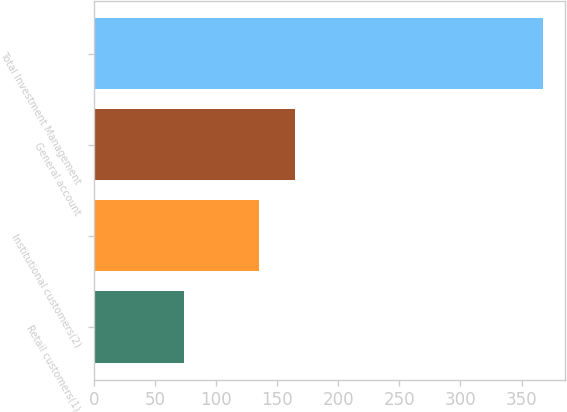Convert chart to OTSL. <chart><loc_0><loc_0><loc_500><loc_500><bar_chart><fcel>Retail customers(1)<fcel>Institutional customers(2)<fcel>General account<fcel>Total Investment Management<nl><fcel>73.5<fcel>134.7<fcel>164.09<fcel>367.4<nl></chart> 